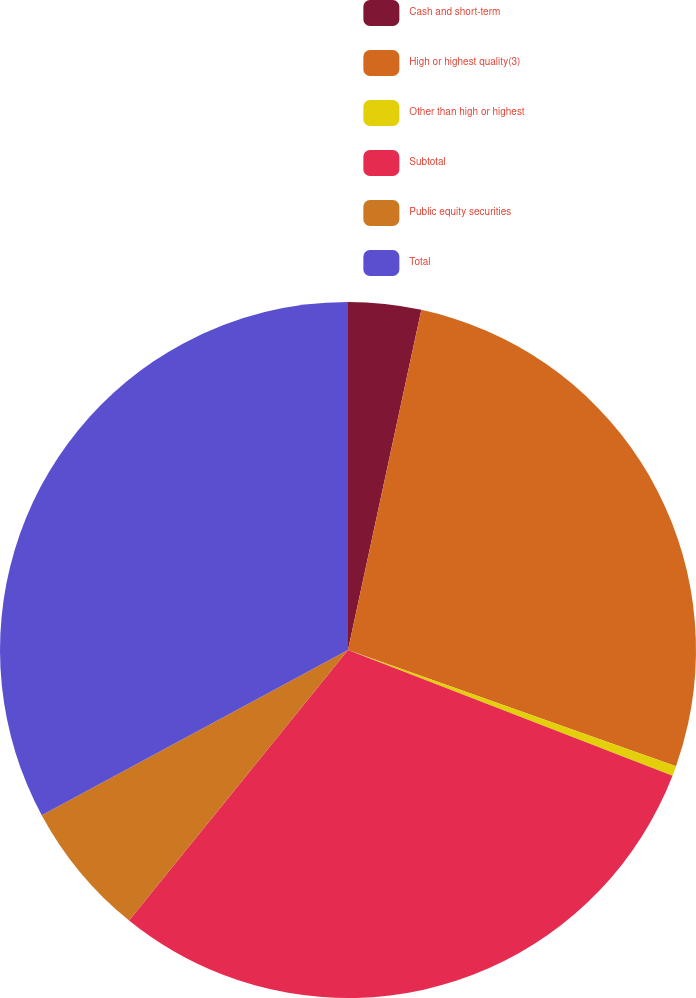Convert chart. <chart><loc_0><loc_0><loc_500><loc_500><pie_chart><fcel>Cash and short-term<fcel>High or highest quality(3)<fcel>Other than high or highest<fcel>Subtotal<fcel>Public equity securities<fcel>Total<nl><fcel>3.38%<fcel>27.04%<fcel>0.46%<fcel>29.95%<fcel>6.3%<fcel>32.87%<nl></chart> 